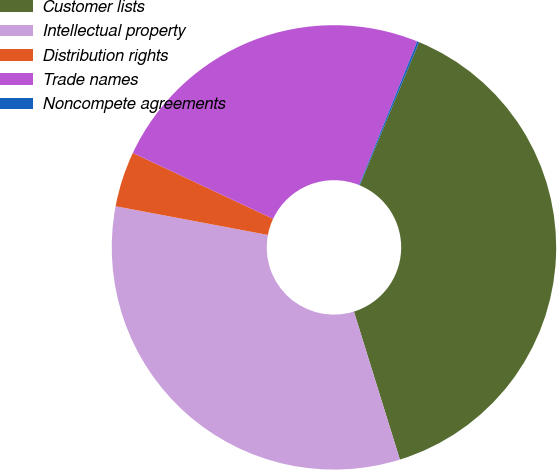Convert chart to OTSL. <chart><loc_0><loc_0><loc_500><loc_500><pie_chart><fcel>Customer lists<fcel>Intellectual property<fcel>Distribution rights<fcel>Trade names<fcel>Noncompete agreements<nl><fcel>38.95%<fcel>32.76%<fcel>4.02%<fcel>24.13%<fcel>0.14%<nl></chart> 